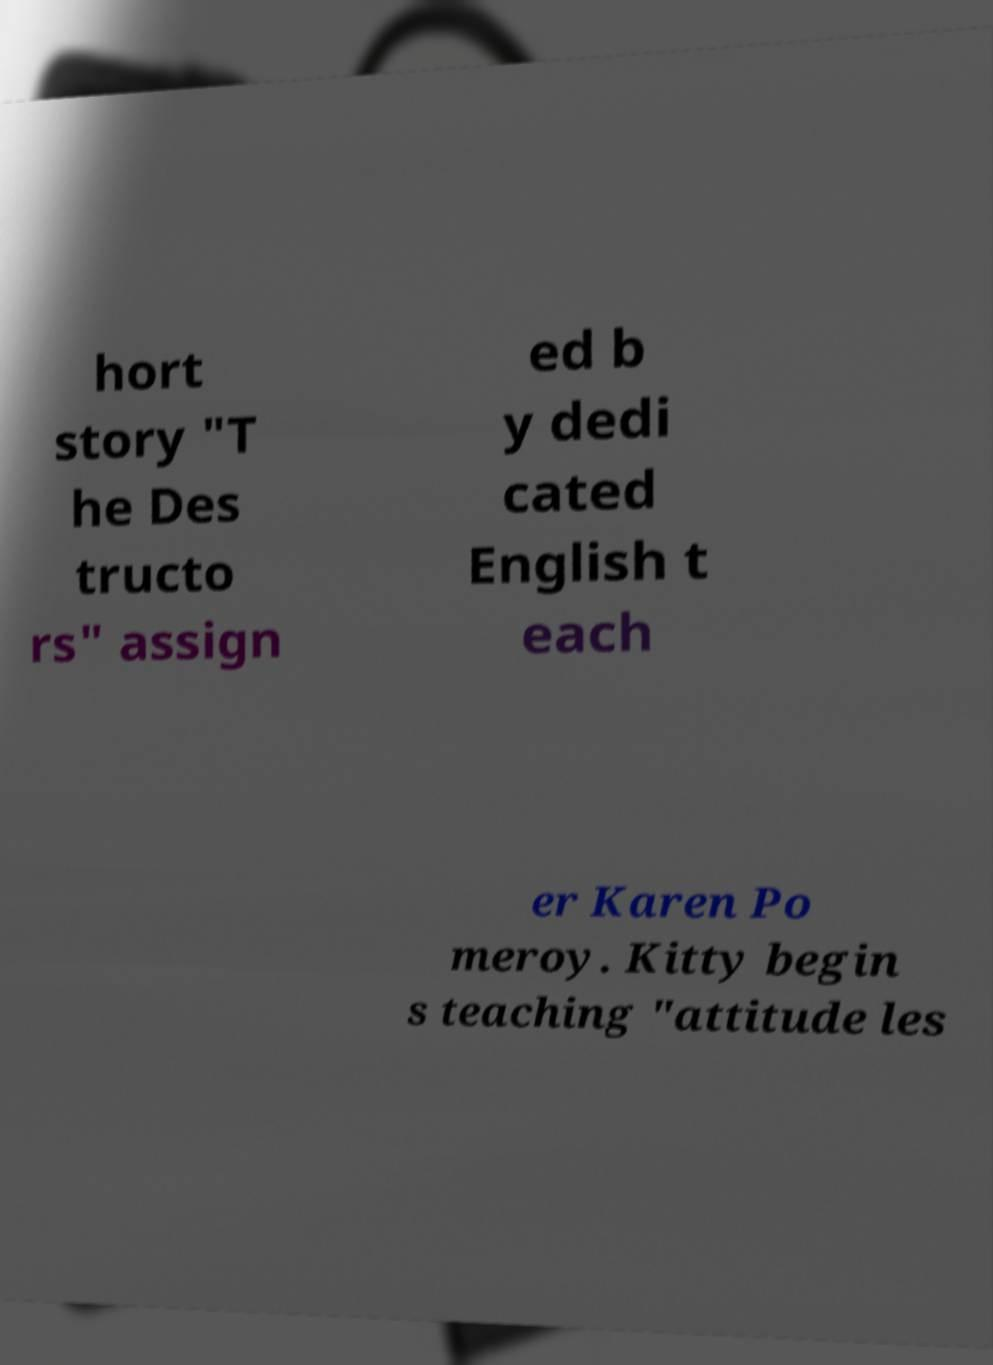There's text embedded in this image that I need extracted. Can you transcribe it verbatim? hort story "T he Des tructo rs" assign ed b y dedi cated English t each er Karen Po meroy. Kitty begin s teaching "attitude les 